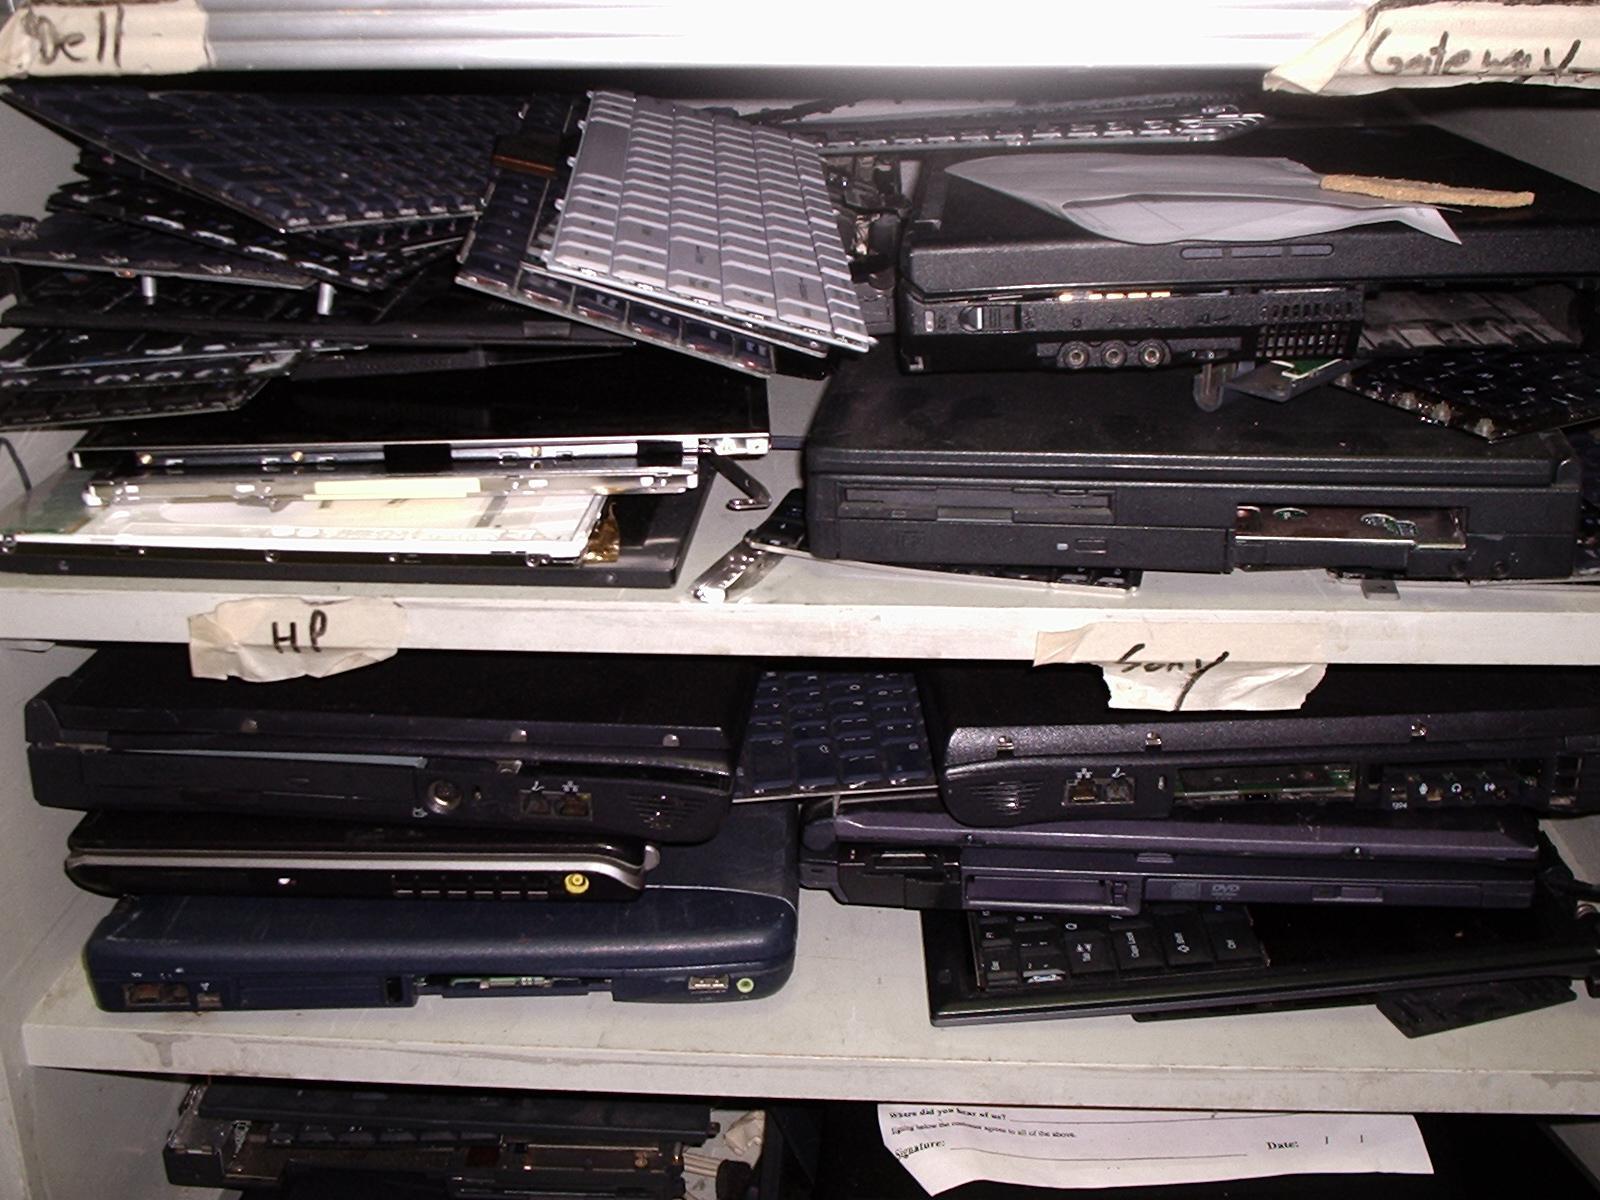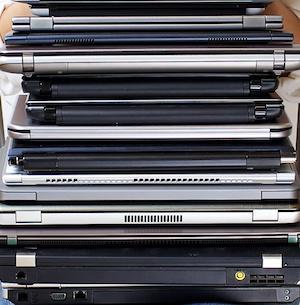The first image is the image on the left, the second image is the image on the right. For the images displayed, is the sentence "In one image at least one laptop is open." factually correct? Answer yes or no. No. 